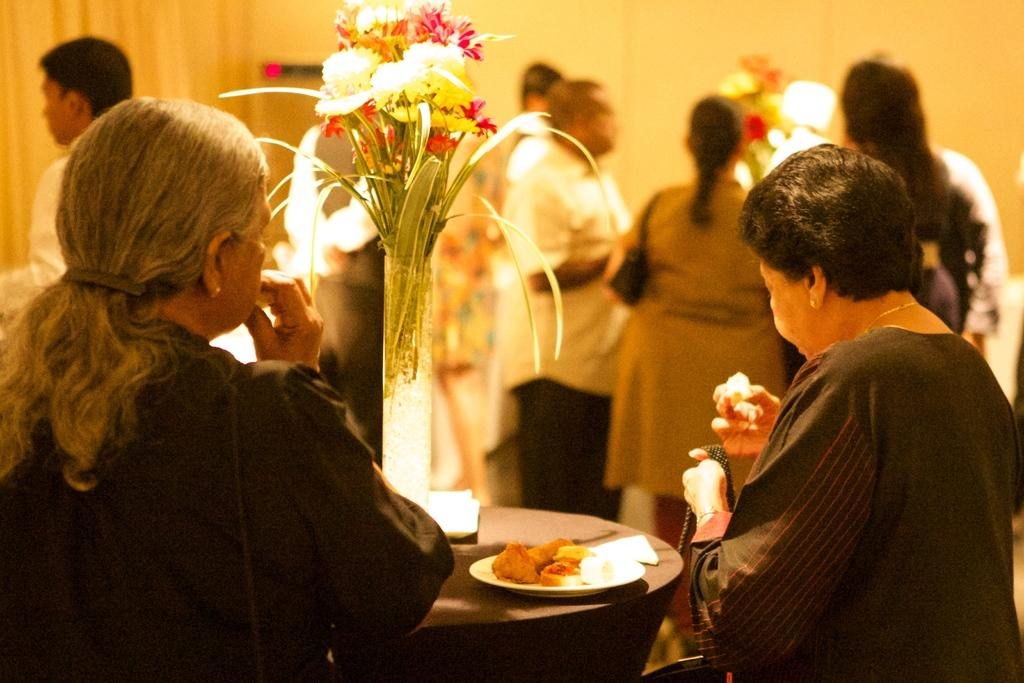What can be seen in the image involving people? There are people standing in the image. What are the people holding in their hands? The people are holding something, but the specific item is not mentioned in the facts. What is visible in the background of the image? There is a table in the background. What objects can be seen on the table? There is a flower vase and a plate on the table. What is on the plate? There is food in the plate. What type of advice can be heard being given during the rainstorm in the image? There is no rainstorm present in the image, and therefore no advice-giving can be observed. 